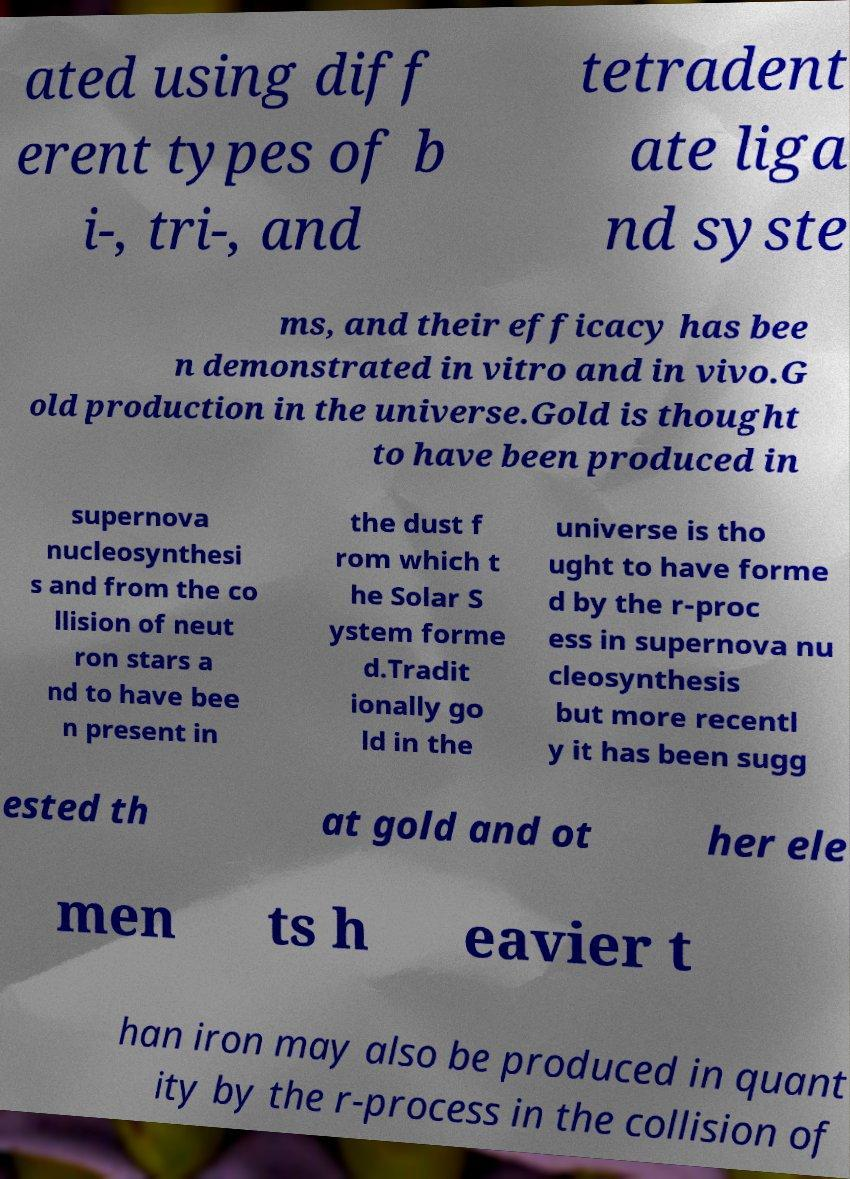For documentation purposes, I need the text within this image transcribed. Could you provide that? ated using diff erent types of b i-, tri-, and tetradent ate liga nd syste ms, and their efficacy has bee n demonstrated in vitro and in vivo.G old production in the universe.Gold is thought to have been produced in supernova nucleosynthesi s and from the co llision of neut ron stars a nd to have bee n present in the dust f rom which t he Solar S ystem forme d.Tradit ionally go ld in the universe is tho ught to have forme d by the r-proc ess in supernova nu cleosynthesis but more recentl y it has been sugg ested th at gold and ot her ele men ts h eavier t han iron may also be produced in quant ity by the r-process in the collision of 